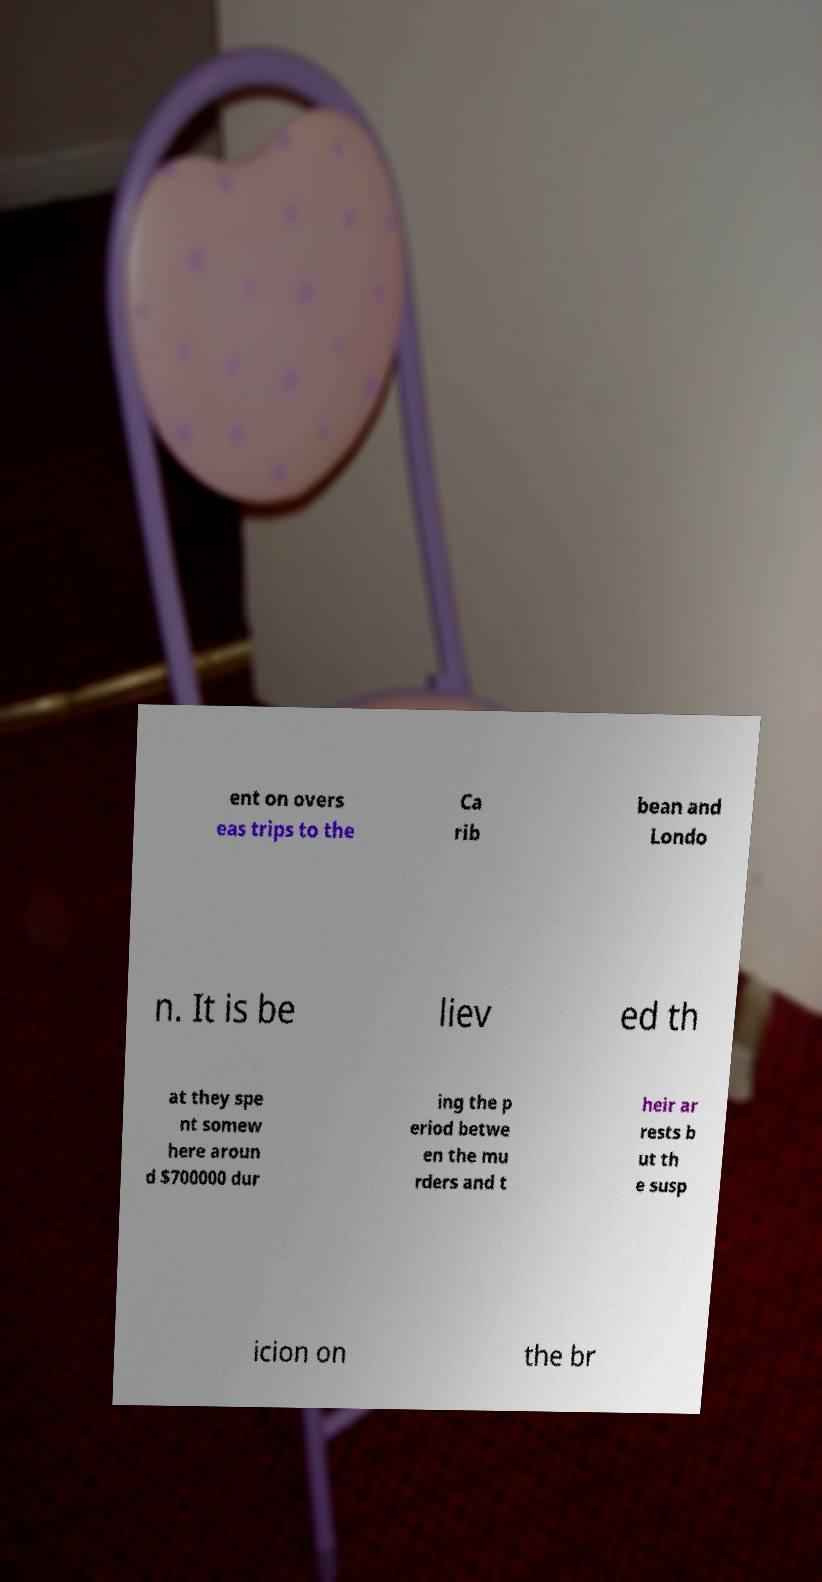For documentation purposes, I need the text within this image transcribed. Could you provide that? ent on overs eas trips to the Ca rib bean and Londo n. It is be liev ed th at they spe nt somew here aroun d $700000 dur ing the p eriod betwe en the mu rders and t heir ar rests b ut th e susp icion on the br 